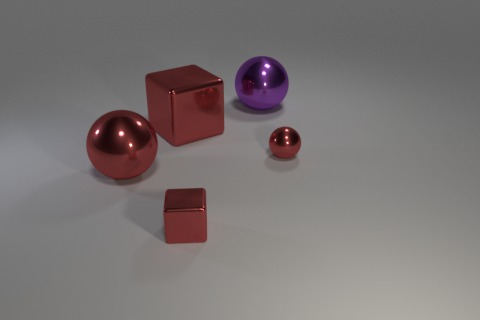Subtract all blue spheres. Subtract all green cubes. How many spheres are left? 3 Add 4 large cubes. How many objects exist? 9 Subtract all cubes. How many objects are left? 3 Add 5 big red shiny spheres. How many big red shiny spheres are left? 6 Add 2 big purple metallic balls. How many big purple metallic balls exist? 3 Subtract 2 red blocks. How many objects are left? 3 Subtract all tiny red spheres. Subtract all small brown rubber balls. How many objects are left? 4 